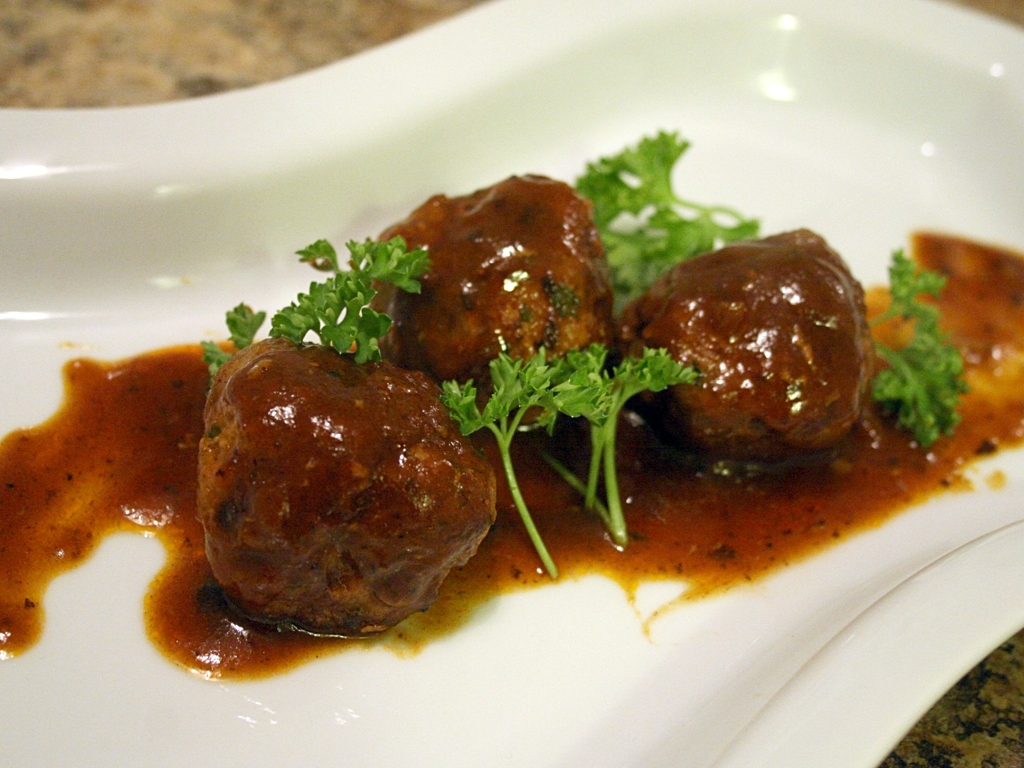Could you suggest a suitable side dish to accompany these meatballs? A perfect accompaniment to these meatballs might be a side of creamy mashed potatoes or a fragrant rice pilaf. These sides would balance well with the richness of the meatballs, while also providing a delightful contrast in textures. Additionally, a serving of steamed vegetables or a crisp salad could provide a refreshing contrast to the savory main dish. 